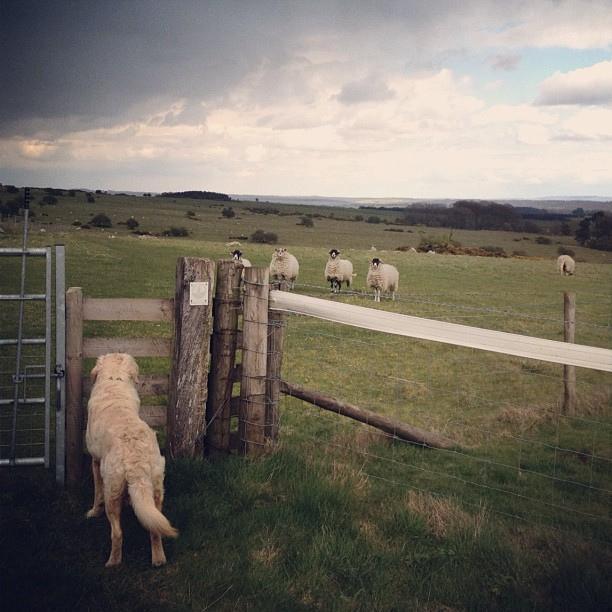How many sheep are in the field?
Give a very brief answer. 5. How many dogs?
Give a very brief answer. 1. How many dogs are lying down?
Give a very brief answer. 0. 